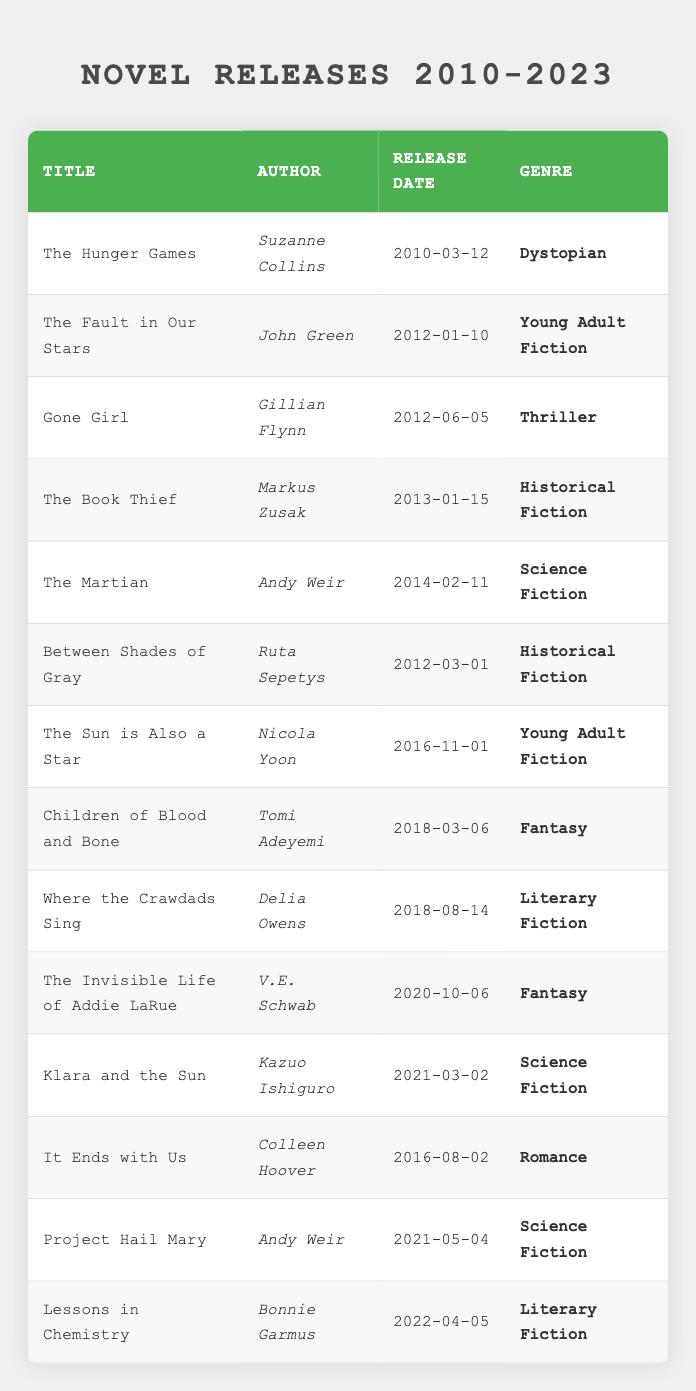What is the release date of "Gone Girl"? The table lists "Gone Girl" in the row for this title, and the associated release date is in the same row under the "Release Date" column. Therefore, the release date for "Gone Girl" is 2012-06-05.
Answer: 2012-06-05 Which novel was released in 2014? By examining the release dates in the table, the only novel listed in 2014 is "The Martian". It can be found in its respective row with the release date noted.
Answer: The Martian How many novels belong to the genre "Fantasy"? In the table, there are two entries marked with the genre "Fantasy". By examining the "Genre" column, we see "Children of Blood and Bone" and "The Invisible Life of Addie LaRue" listed under that genre. Thus, the count is 2.
Answer: 2 Is "The Fault in Our Stars" a Young Adult Fiction? Looking at the genre listed in the table for "The Fault in Our Stars", it is indeed classified under "Young Adult Fiction". Therefore, the answer is yes.
Answer: Yes Which author has the most novels listed in the table? By checking the "Author" column, we find that "Andy Weir" appears twice with "The Martian" and "Project Hail Mary". Hence, he has the most novels, totaling 2.
Answer: 2 What is the average release year of the novels listed? The years from the release dates (2010, 2012, 2012, 2013, 2014, 2012, 2016, 2018, 2018, 2020, 2021, 2016, 2021, 2022) add up to a total of 2020. There are 14 novels, therefore the average year is 2020/14, which gives approximately 2015.14, or, rounded down, 2015.
Answer: 2015 Has any novel by Colleen Hoover been released before 2015? The table lists "It Ends with Us" by Colleen Hoover released in 2016. Since no entries for her name are found prior to this year, the answer is no.
Answer: No What is the most recent genre listed, and which novel belongs to it? The most recent novel listed is "Lessons in Chemistry" with a release date of 2022. The genre associated with this novel is "Literary Fiction."
Answer: Literary Fiction, Lessons in Chemistry 